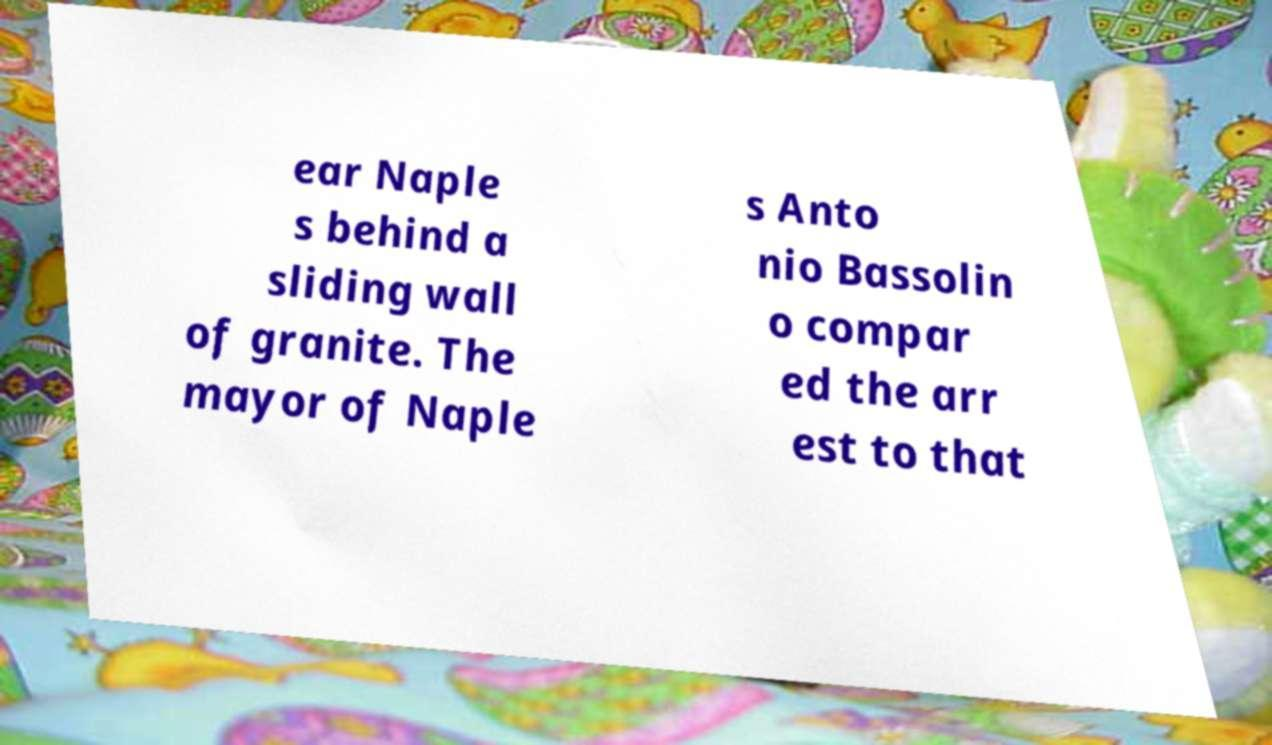Please read and relay the text visible in this image. What does it say? ear Naple s behind a sliding wall of granite. The mayor of Naple s Anto nio Bassolin o compar ed the arr est to that 